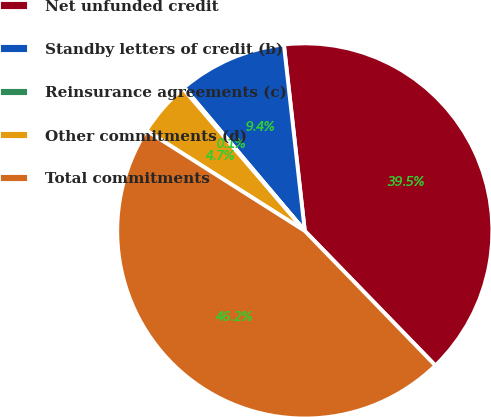Convert chart. <chart><loc_0><loc_0><loc_500><loc_500><pie_chart><fcel>Net unfunded credit<fcel>Standby letters of credit (b)<fcel>Reinsurance agreements (c)<fcel>Other commitments (d)<fcel>Total commitments<nl><fcel>39.52%<fcel>9.36%<fcel>0.13%<fcel>4.74%<fcel>46.25%<nl></chart> 